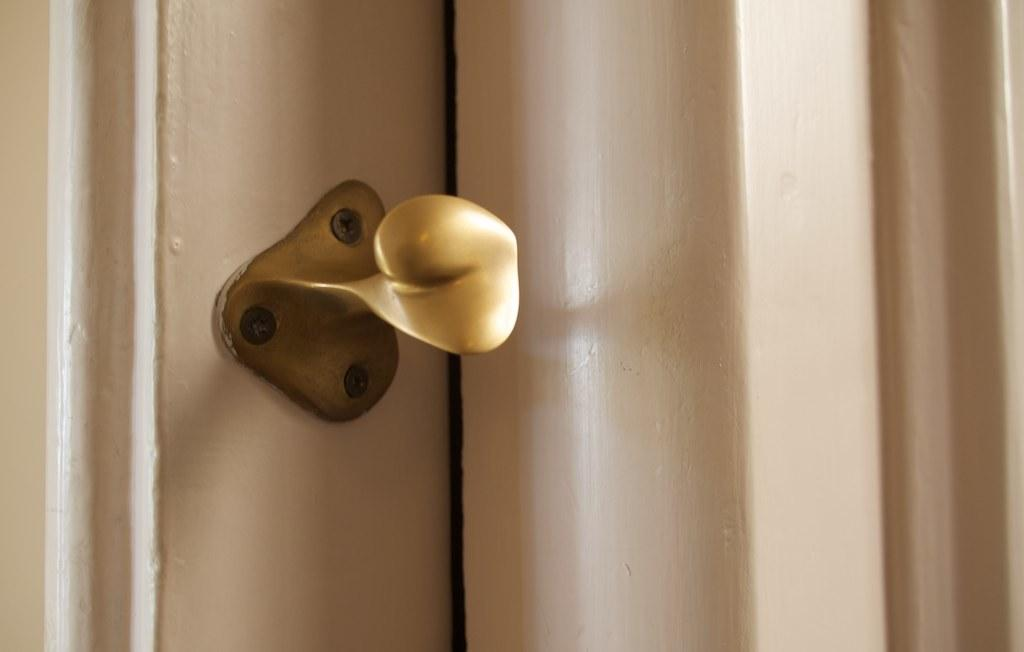What is the main object in the image? There is a door in the image. How many toes does the son have in the image? There is no son or mention of toes in the image; it only features a door. What type of army is depicted in the image? There is no army or any military-related elements present in the image; it only features a door. 